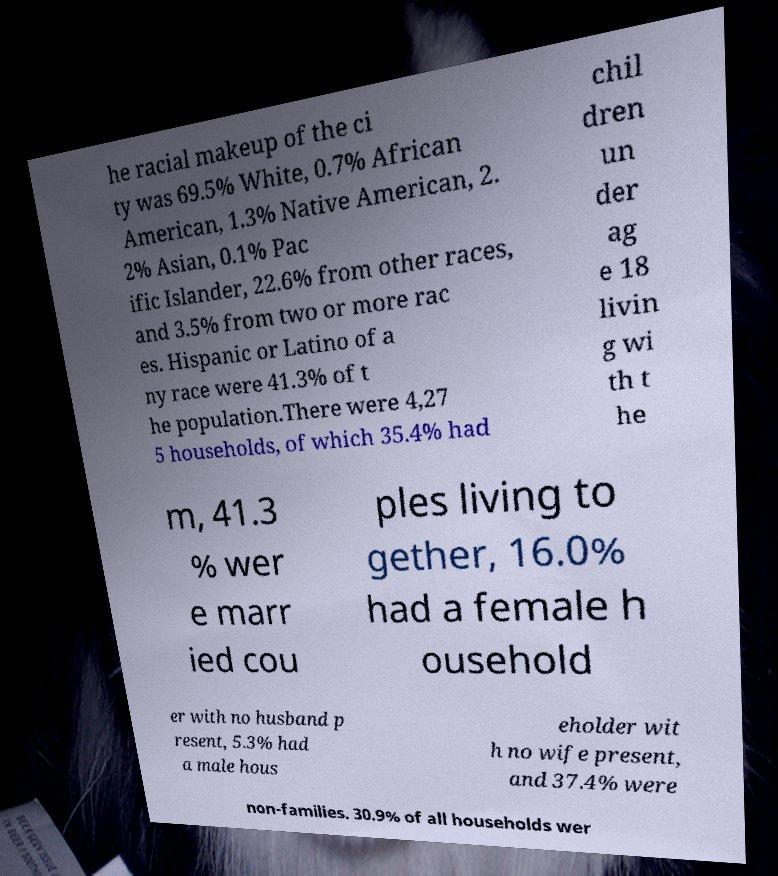I need the written content from this picture converted into text. Can you do that? he racial makeup of the ci ty was 69.5% White, 0.7% African American, 1.3% Native American, 2. 2% Asian, 0.1% Pac ific Islander, 22.6% from other races, and 3.5% from two or more rac es. Hispanic or Latino of a ny race were 41.3% of t he population.There were 4,27 5 households, of which 35.4% had chil dren un der ag e 18 livin g wi th t he m, 41.3 % wer e marr ied cou ples living to gether, 16.0% had a female h ousehold er with no husband p resent, 5.3% had a male hous eholder wit h no wife present, and 37.4% were non-families. 30.9% of all households wer 